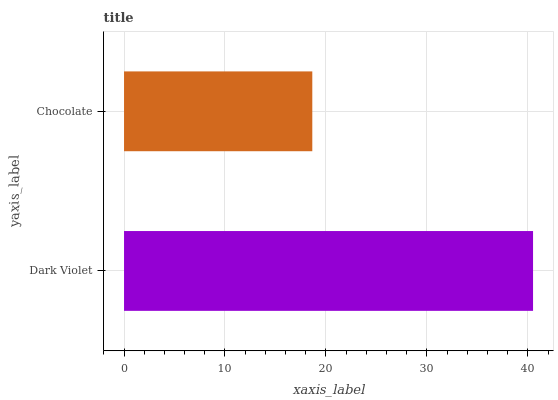Is Chocolate the minimum?
Answer yes or no. Yes. Is Dark Violet the maximum?
Answer yes or no. Yes. Is Chocolate the maximum?
Answer yes or no. No. Is Dark Violet greater than Chocolate?
Answer yes or no. Yes. Is Chocolate less than Dark Violet?
Answer yes or no. Yes. Is Chocolate greater than Dark Violet?
Answer yes or no. No. Is Dark Violet less than Chocolate?
Answer yes or no. No. Is Dark Violet the high median?
Answer yes or no. Yes. Is Chocolate the low median?
Answer yes or no. Yes. Is Chocolate the high median?
Answer yes or no. No. Is Dark Violet the low median?
Answer yes or no. No. 